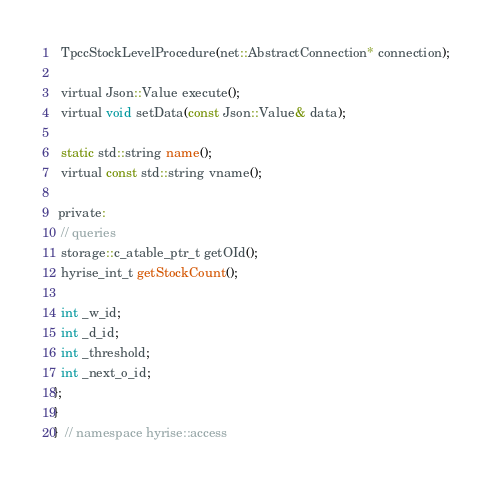<code> <loc_0><loc_0><loc_500><loc_500><_C_>  TpccStockLevelProcedure(net::AbstractConnection* connection);

  virtual Json::Value execute();
  virtual void setData(const Json::Value& data);

  static std::string name();
  virtual const std::string vname();

 private:
  // queries
  storage::c_atable_ptr_t getOId();
  hyrise_int_t getStockCount();

  int _w_id;
  int _d_id;
  int _threshold;
  int _next_o_id;
};
}
}  // namespace hyrise::access
</code> 